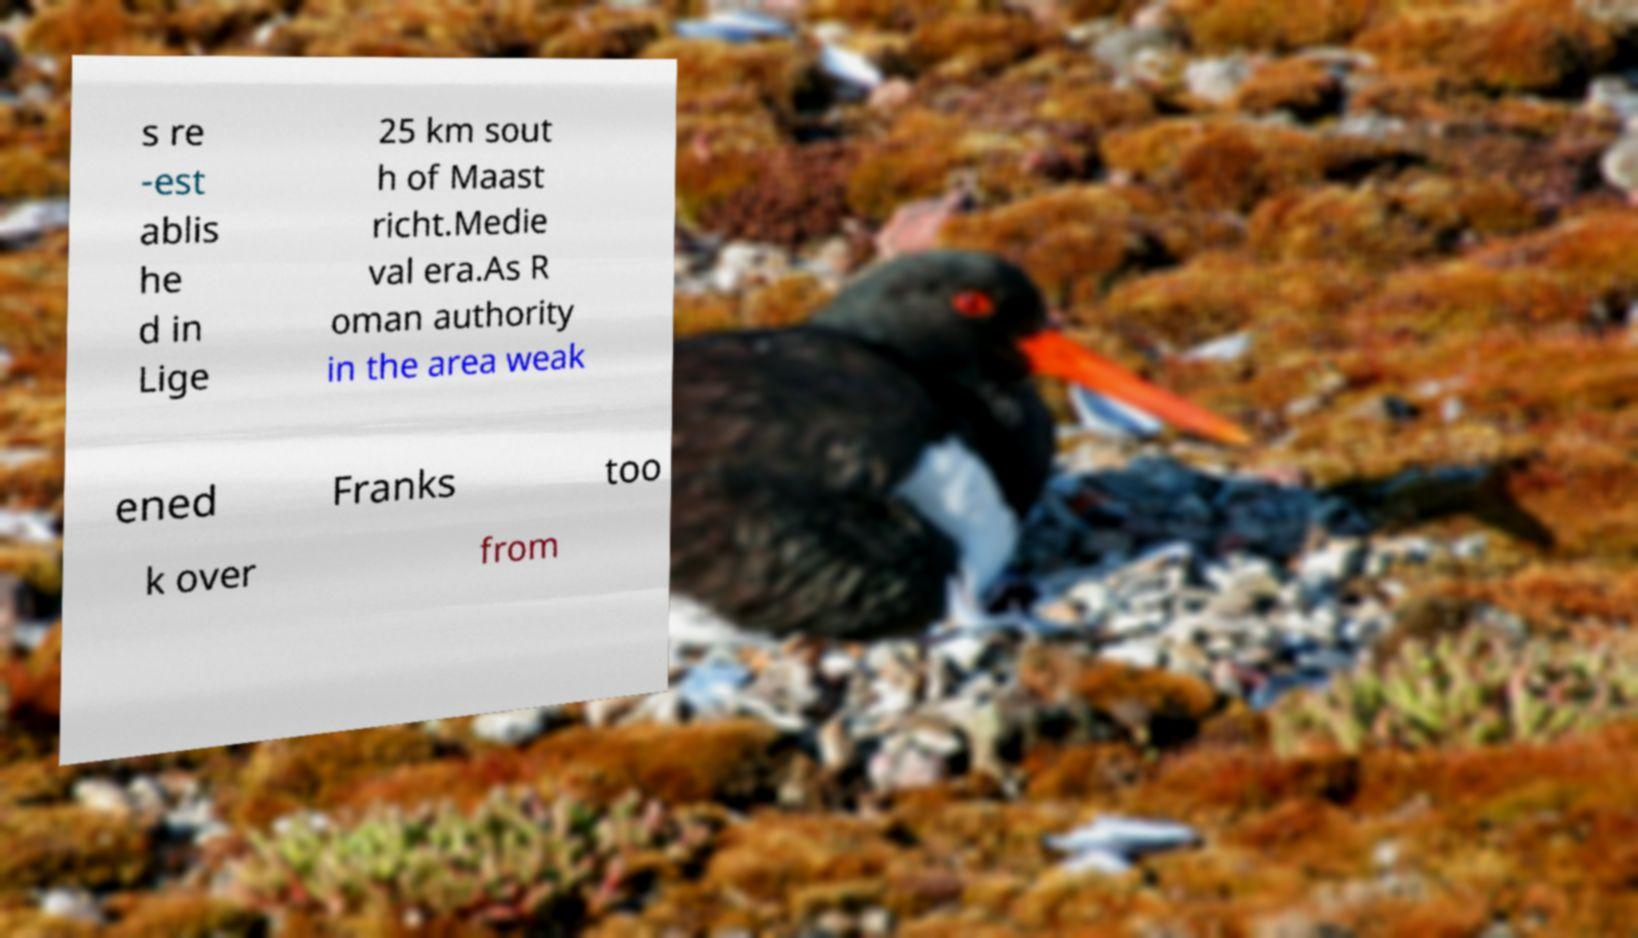Can you read and provide the text displayed in the image?This photo seems to have some interesting text. Can you extract and type it out for me? s re -est ablis he d in Lige 25 km sout h of Maast richt.Medie val era.As R oman authority in the area weak ened Franks too k over from 